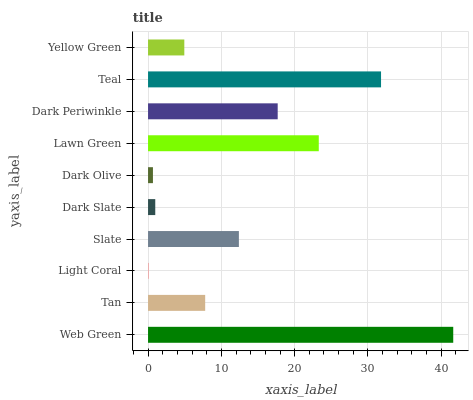Is Light Coral the minimum?
Answer yes or no. Yes. Is Web Green the maximum?
Answer yes or no. Yes. Is Tan the minimum?
Answer yes or no. No. Is Tan the maximum?
Answer yes or no. No. Is Web Green greater than Tan?
Answer yes or no. Yes. Is Tan less than Web Green?
Answer yes or no. Yes. Is Tan greater than Web Green?
Answer yes or no. No. Is Web Green less than Tan?
Answer yes or no. No. Is Slate the high median?
Answer yes or no. Yes. Is Tan the low median?
Answer yes or no. Yes. Is Teal the high median?
Answer yes or no. No. Is Lawn Green the low median?
Answer yes or no. No. 